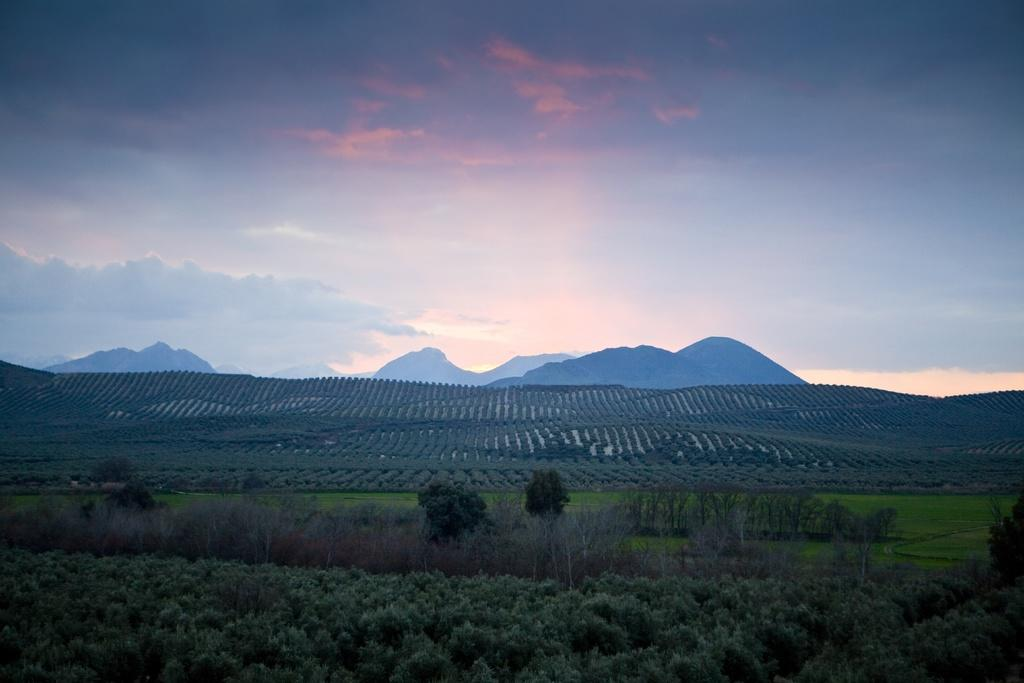What type of natural landform is visible in the image? There are mountains in the image. What type of vegetation can be seen in the image? There are green color trees and dry trees in the image. What colors are present in the sky in the image? The sky is blue, orange, and white in color. What type of alarm can be heard going off in the image? There is no alarm present in the image, as it is a landscape featuring mountains, trees, and a sky. What type of building can be seen in the image? There is no building present in the image; it is a landscape featuring mountains, trees, and a sky. 